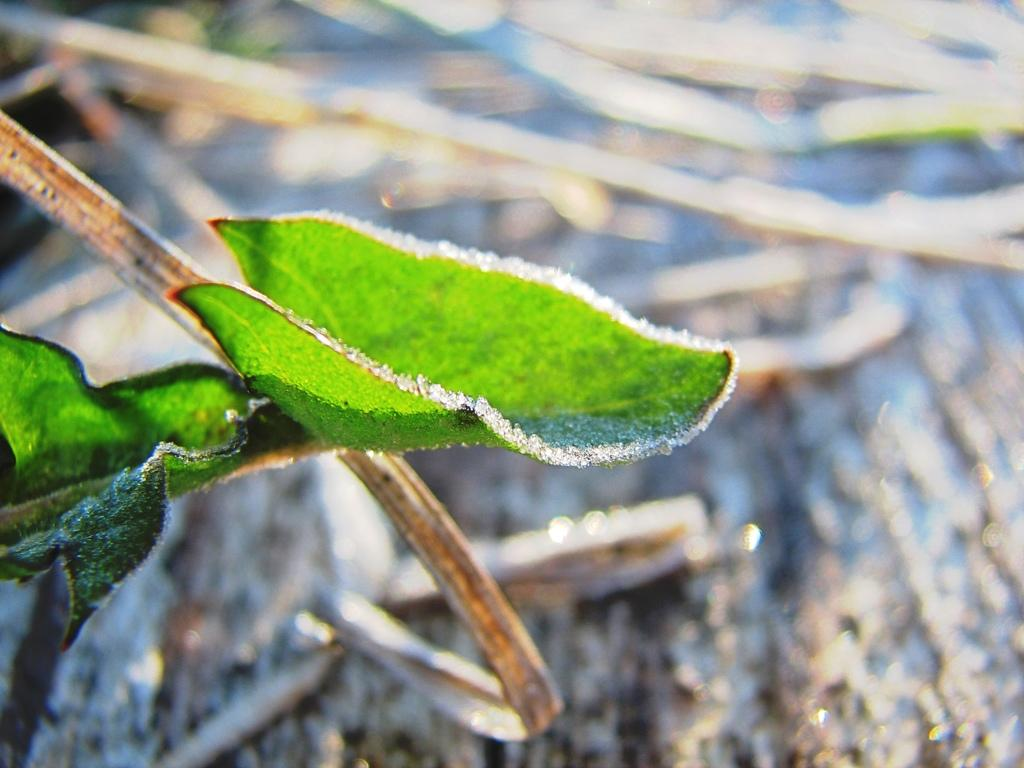What type of vegetation can be seen in the image? There are leaves in the image. What type of railway is depicted in the image? There is no railway present in the image; it only features leaves. What role does the army play in the image? There is no army depicted in the image; it only features leaves. 